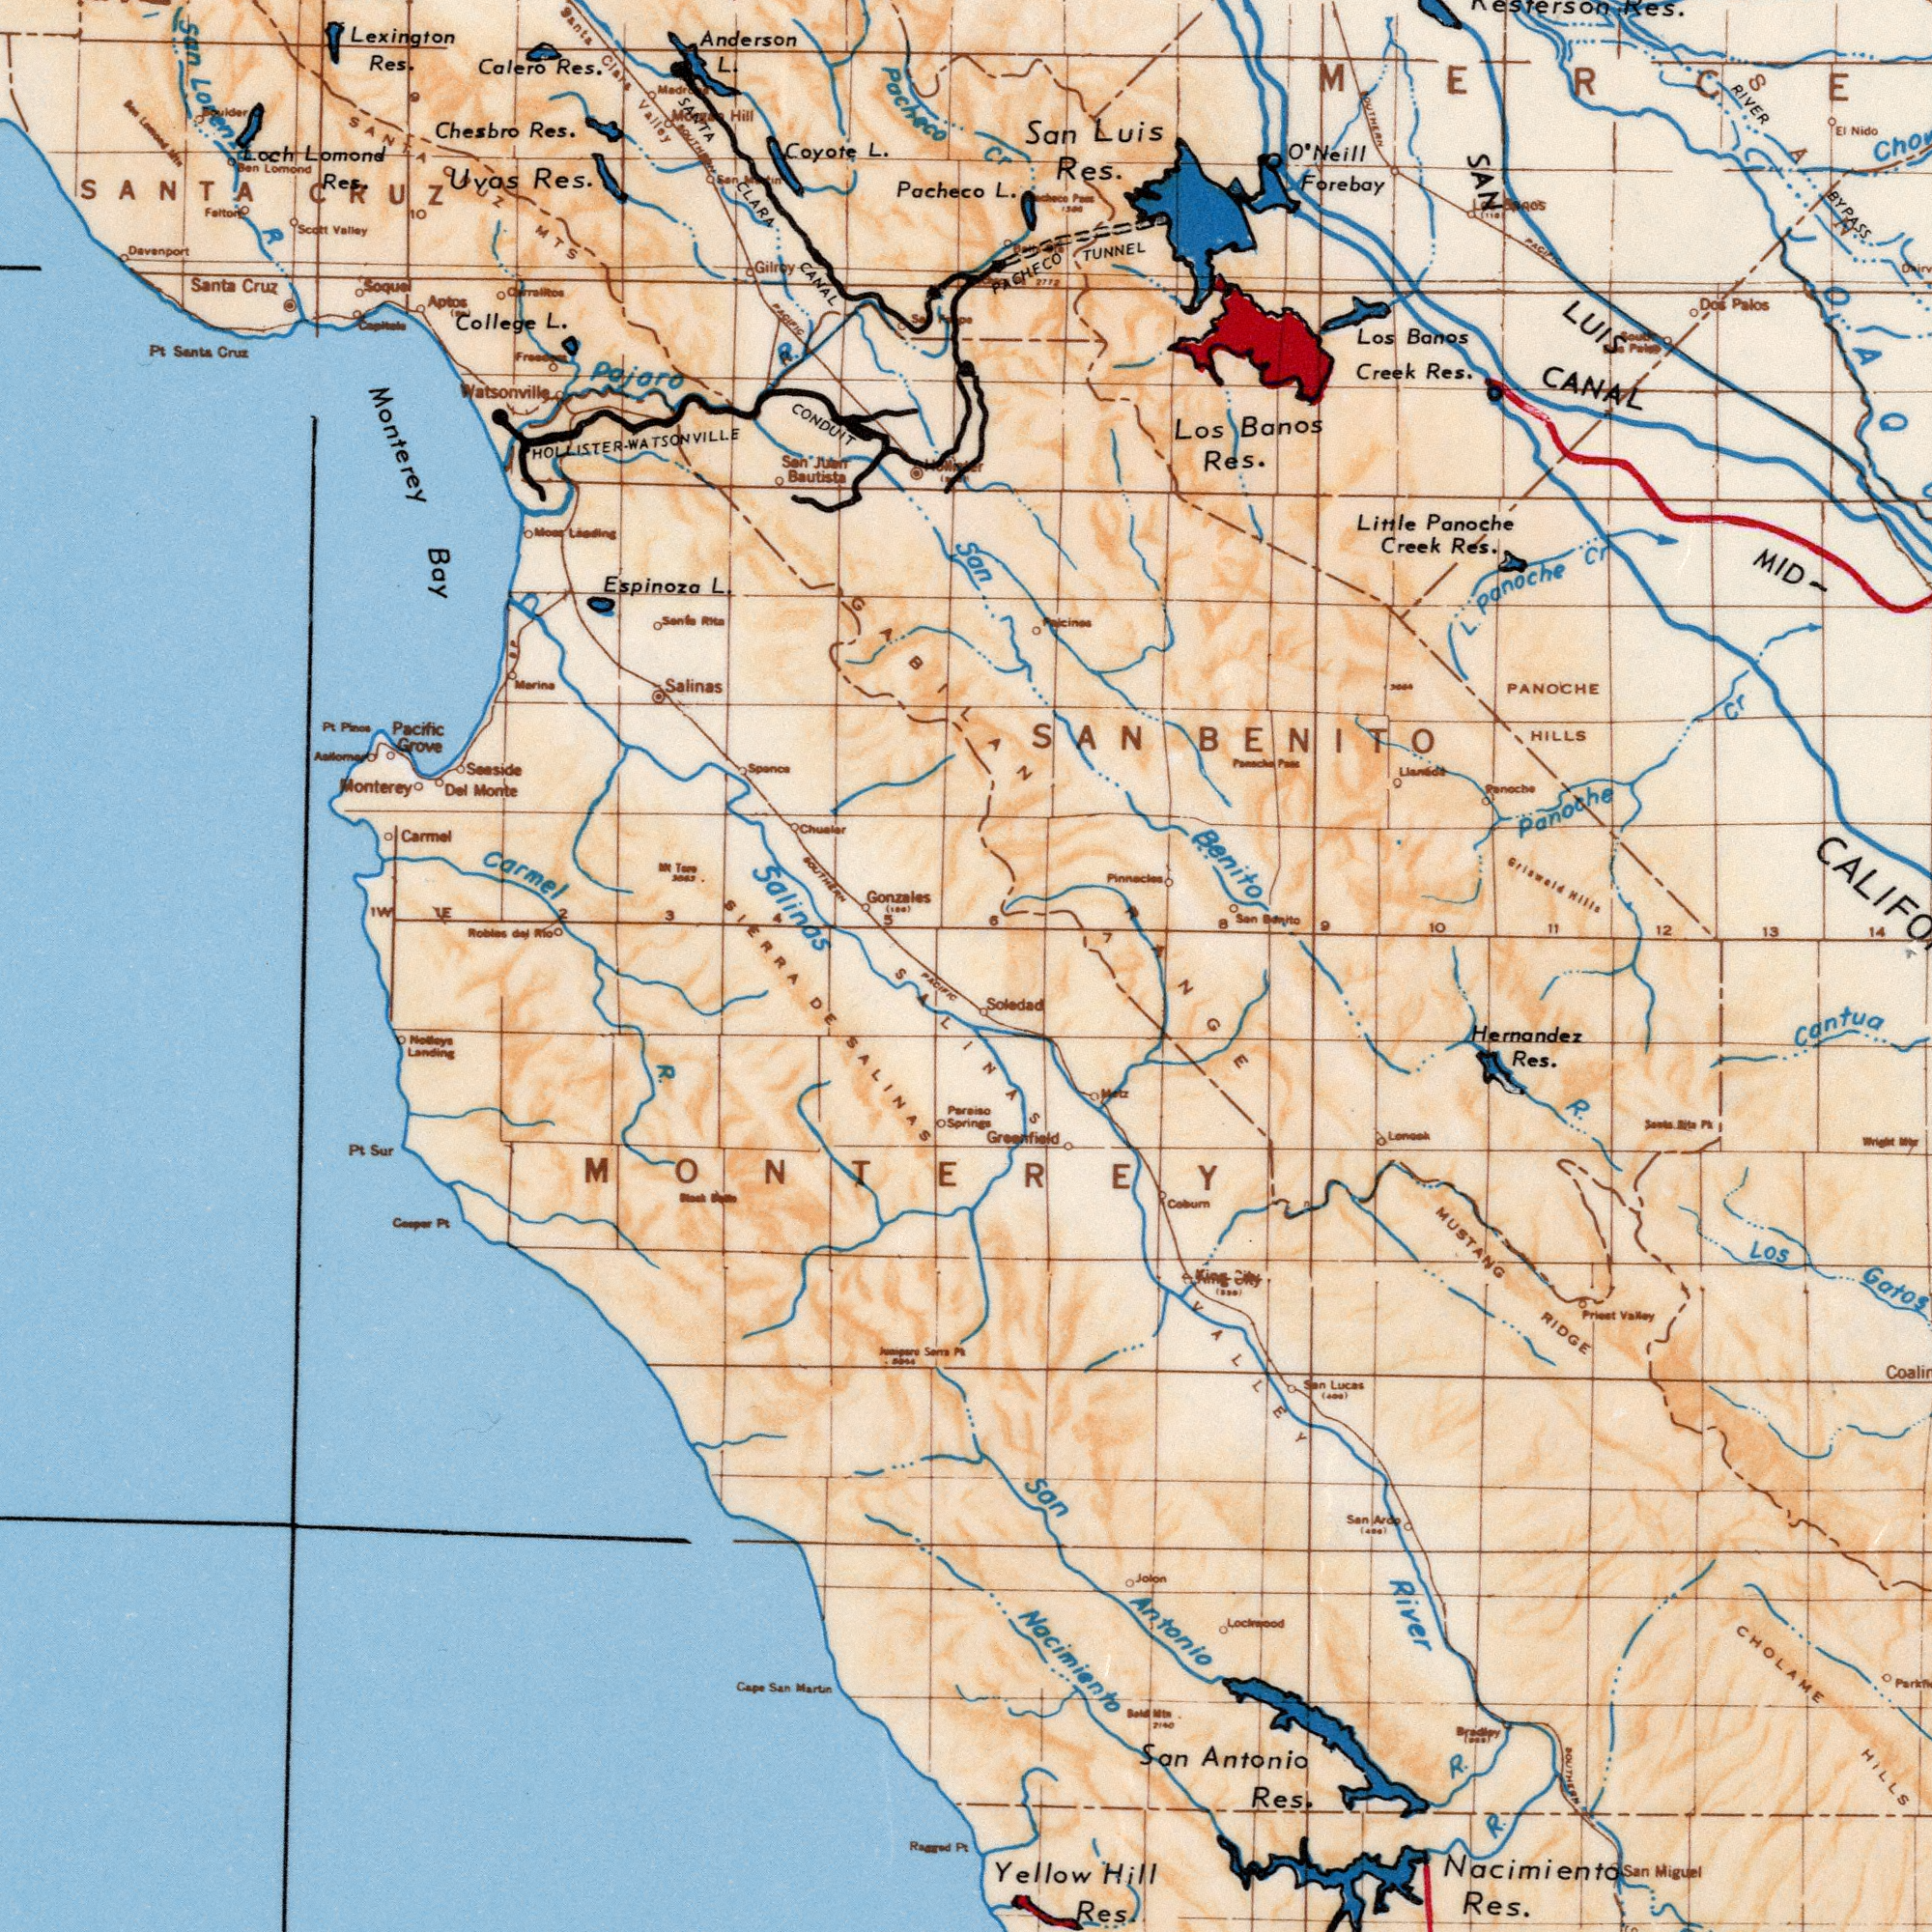What text is shown in the bottom-right quadrant? Nacimiento Antonio Yellow Antonio Hernandez CHOLAME VALLEY HILLS RIDGE R. Cantua Res. Soledad Gatos Res. San San Los Hill Res. MUSTANG R. Nacimiento Res. River Miguel Greenfield Jolon San King R. Metz Lockwood RANGE Priest Valley Santa Pt San Lucas San 7140 Bradley City SOUTHERN What text is visible in the upper-left corner? Salinas Monterey Pacheco Lexington CANAL Carmel Bay Coyote Pajaro Espinoza Chesbro Res. Res. SANTA College Pacheco Res. SANTA Res. Santa CONDUIT CLARA L. Monte L. Salinas Gonzales L. Cruz R. Monterey Santa L. Res. Calero Lomond Santa Uvas Vatsonville Valley Bautista Pacific Davenport Anderson Gilroy Del Carmel Cruz Grove Pacific Pt. Loren Seaside Loch Clara Valley 10 Hill San Pt MTS 3 R San 1W SOUTHERN Falton 5 Soque Marina Juan San Cr SANTA CRUZ Aptos ###ltos Cepitede 2 Mk Tere Jess 4 SIERRA 1E Chualar GABILAN 6 Moes Leading Santa Spenca (100) CRUZ San Lomond Scott Boulder 9 SOUTHERN San ###n HOLLISTER- WATSONVILLE What text is shown in the bottom-left quadrant? SALINAS DE R. Sur Pt MONTEREY PACIFIC SALINAS Springs Pt Cooper Sam Pt Cape San Martin Ragged Pt Notleys Landing What text can you see in the top-right section? Panoche Panoche Banos LUIS SAN Benito Res. Creek San Los Little Panoche RIVER Res. Banos Luis PACHECO PANOCHE Res. Forebay HILLS Res. Res. BYPASS Creek Los O'Neill Cr L. ###AOS Cr 13 TUNNEL 12 Nido SOUTHERN L. El Hills Palos 10 SAN CANAL 11 BENITO 7 SAN Panoche Griswold 9 8 San Benito Pinnacles 14 ###ou### Pacific 